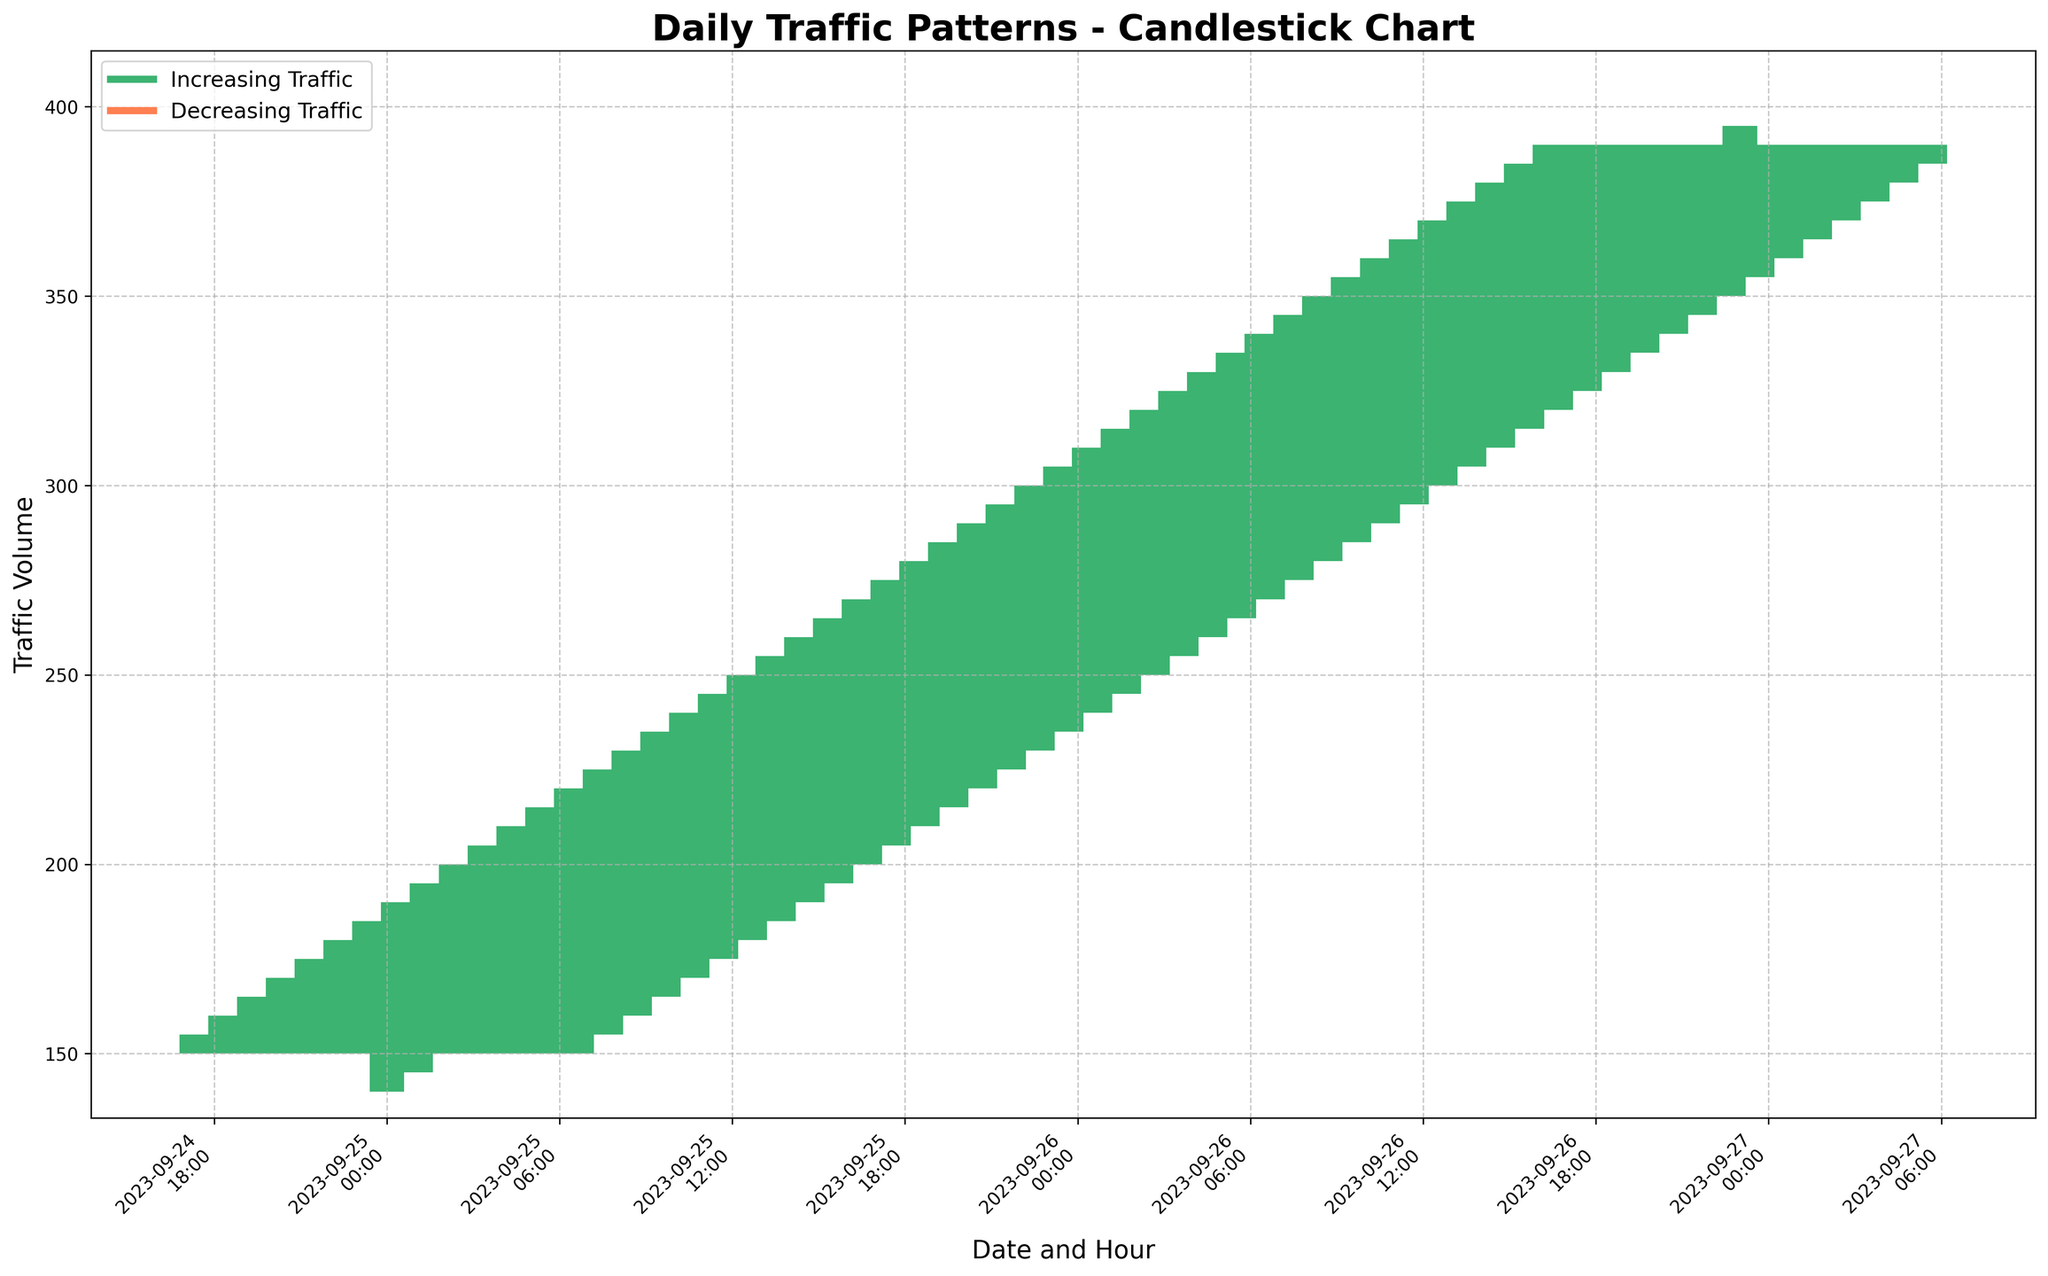What is the title of the plot? The title is at the top of the plot, and it reads, "Daily Traffic Patterns - Candlestick Chart".
Answer: Daily Traffic Patterns - Candlestick Chart What is the time interval used for capturing traffic data? The x-axis labels use 'Date and Hour' showing intervals every hour.
Answer: Hourly What trend is indicated by green bars in the plot? Green bars (mediumseagreen) indicate periods when the traffic volume increased (Close is greater than or equal to Open).
Answer: Increasing Traffic What is the trend represented by red bars in the plot? Red bars (coral) represent periods when the traffic volume decreased (Close is less than Open).
Answer: Decreasing Traffic At what date and hour did the traffic volume first cross 200? The plot shows the first instance of the traffic volume crossing 200 on September 25, from 09:00 to 10:00.
Answer: 2023-09-25 09:00 What is the highest traffic volume recorded during the time period? The plot's y-axis scales up to around 400, but examining the data, the highest volume is 395 at 23:00 on September 26.
Answer: 395 How many times did the traffic decrease from one hour to the next? The plot has red bars representing decreases; count them to find decreases. There are 6 decreases.
Answer: 6 On which date did the highest number of traffic volume increases occur? By counting green bars on each date, September 26 has more green bars compared to September 25.
Answer: 2023-09-26 What is the average traffic volume at 00:00 across both days? Add traffic volumes at 00:00 on both dates (155 and 275 respectively) and divide by 2. (155 + 275) / 2 = 215.
Answer: 215 How does the traffic volume at 06:00 compare on 25th and 26th September? Check both values: 06:00 on 25th is 185, and on 26th it's 305. 305 is greater than 185.
Answer: 26th is greater than 25th 